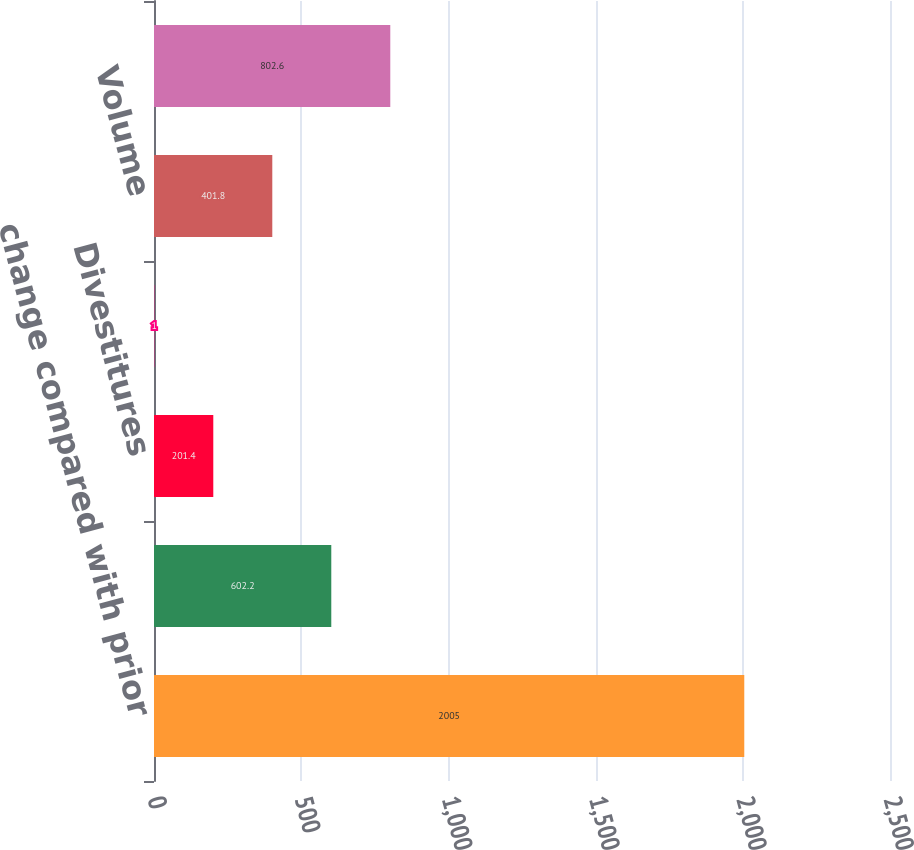<chart> <loc_0><loc_0><loc_500><loc_500><bar_chart><fcel>change compared with prior<fcel>Acquisitions<fcel>Divestitures<fcel>Price<fcel>Volume<fcel>Foreign Exchange<nl><fcel>2005<fcel>602.2<fcel>201.4<fcel>1<fcel>401.8<fcel>802.6<nl></chart> 